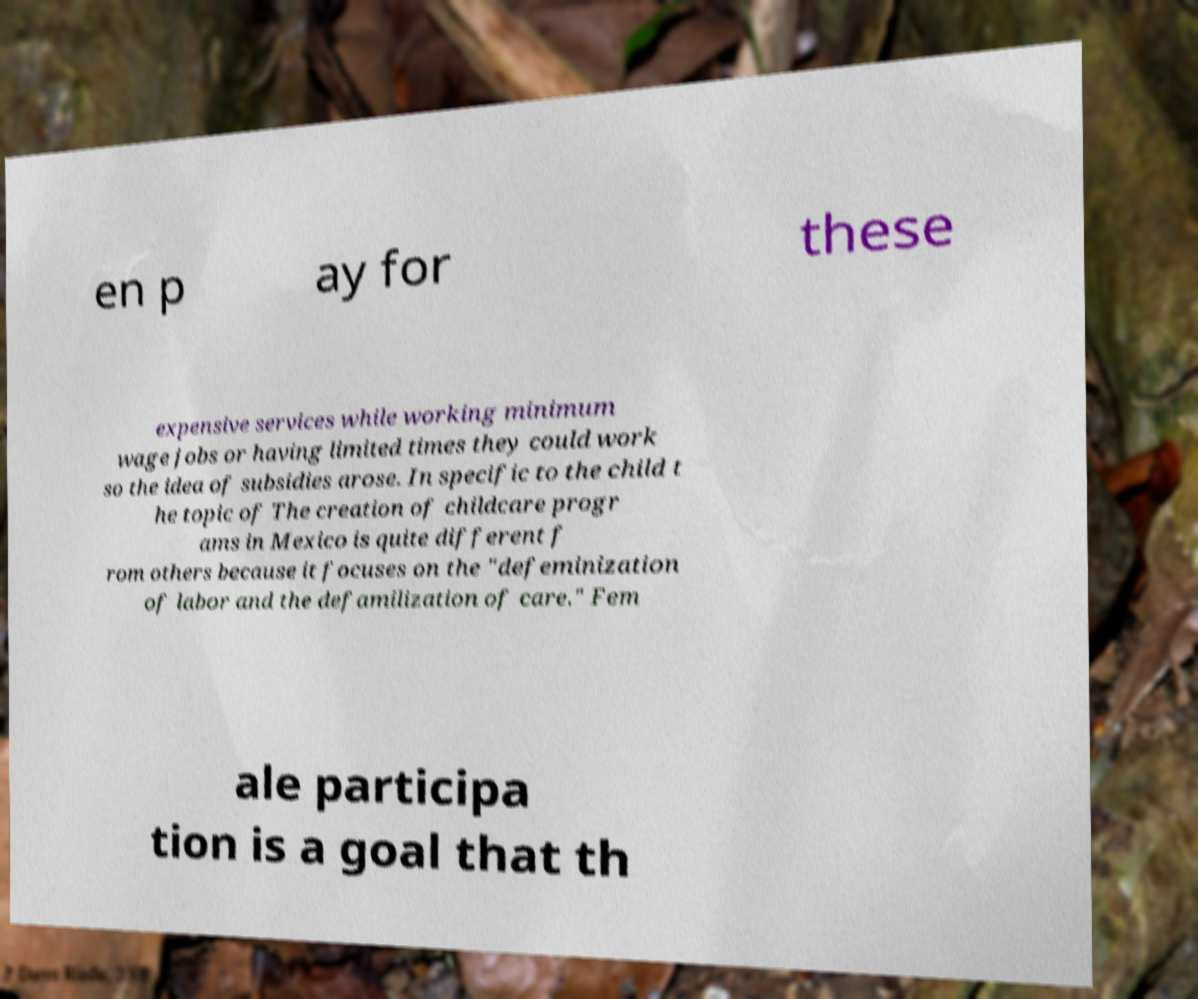Please identify and transcribe the text found in this image. en p ay for these expensive services while working minimum wage jobs or having limited times they could work so the idea of subsidies arose. In specific to the child t he topic of The creation of childcare progr ams in Mexico is quite different f rom others because it focuses on the "defeminization of labor and the defamilization of care." Fem ale participa tion is a goal that th 